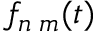<formula> <loc_0><loc_0><loc_500><loc_500>f _ { n \, m } ( t )</formula> 